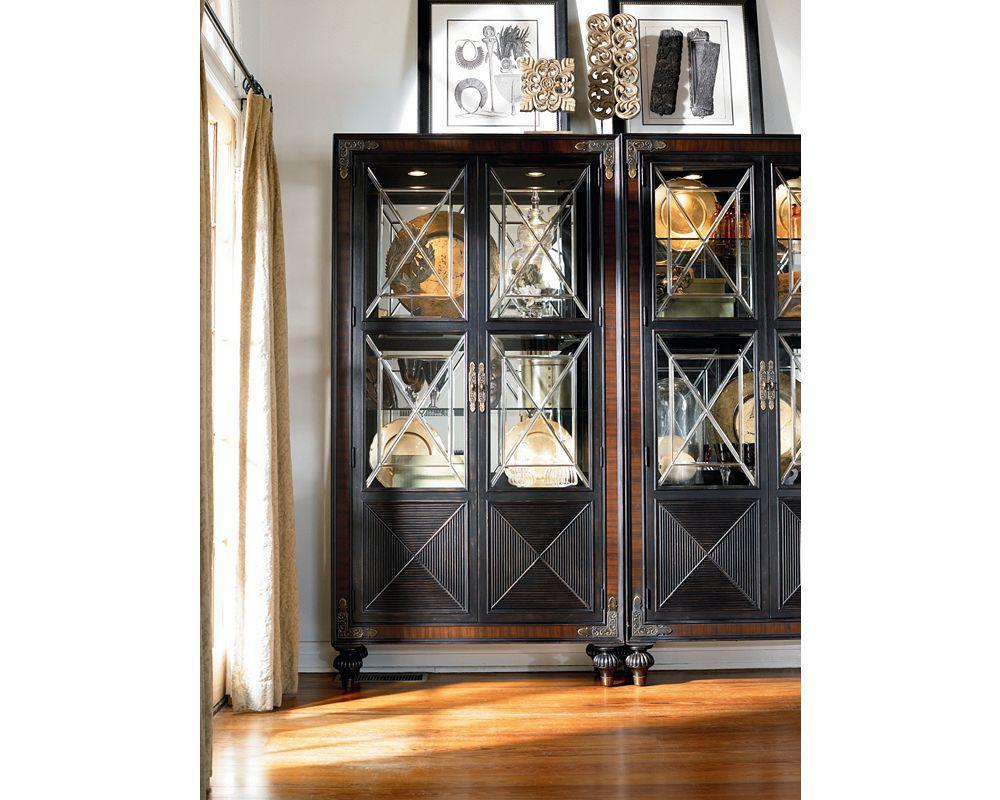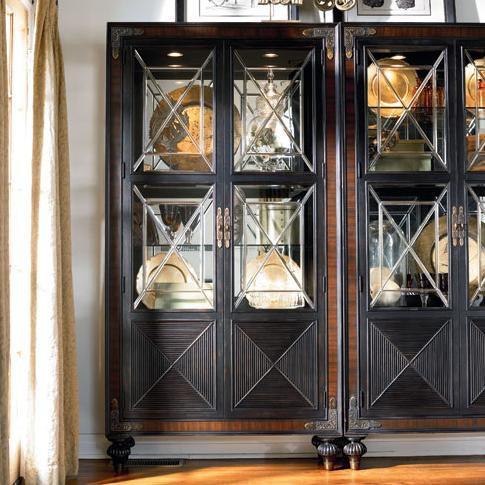The first image is the image on the left, the second image is the image on the right. Examine the images to the left and right. Is the description "The right hand image has a row of three drawers." accurate? Answer yes or no. No. 